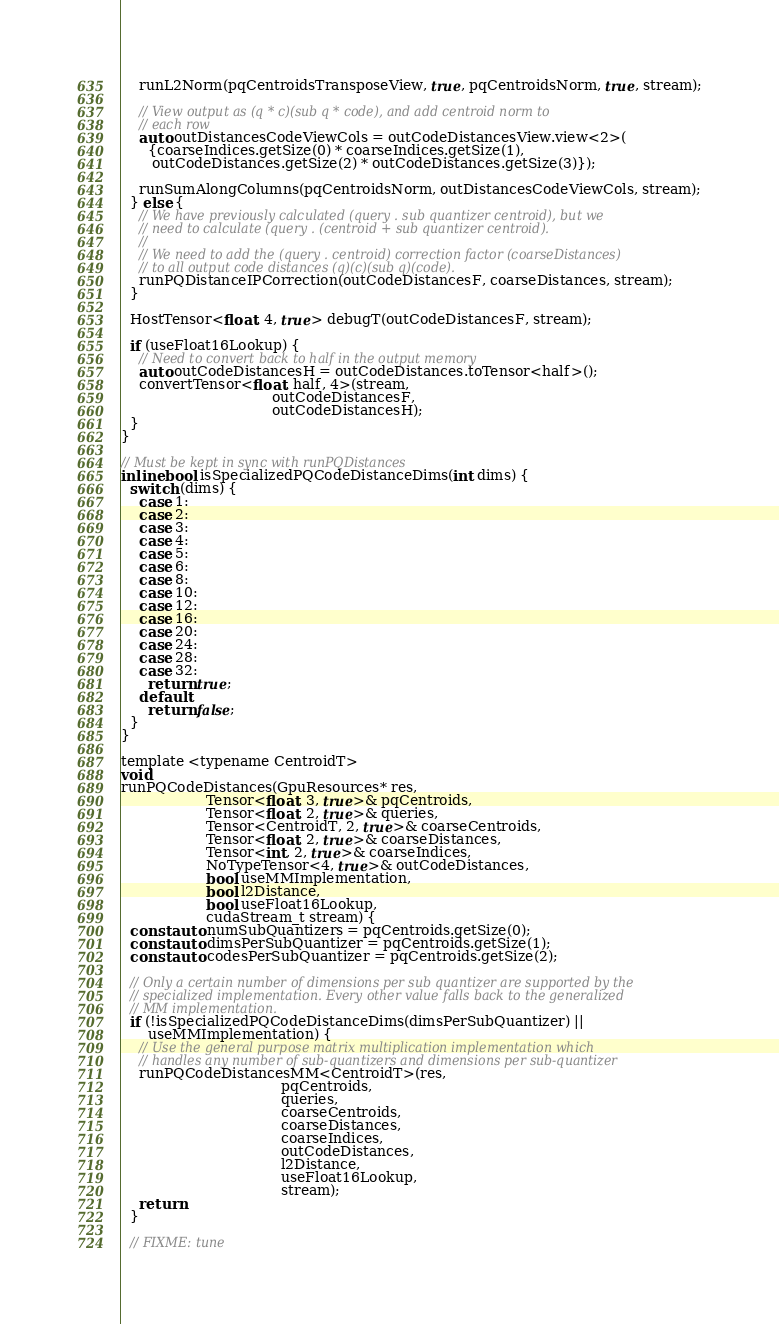<code> <loc_0><loc_0><loc_500><loc_500><_Cuda_>
    runL2Norm(pqCentroidsTransposeView, true, pqCentroidsNorm, true, stream);

    // View output as (q * c)(sub q * code), and add centroid norm to
    // each row
    auto outDistancesCodeViewCols = outCodeDistancesView.view<2>(
      {coarseIndices.getSize(0) * coarseIndices.getSize(1),
       outCodeDistances.getSize(2) * outCodeDistances.getSize(3)});

    runSumAlongColumns(pqCentroidsNorm, outDistancesCodeViewCols, stream);
  } else {
    // We have previously calculated (query . sub quantizer centroid), but we
    // need to calculate (query . (centroid + sub quantizer centroid).
    //
    // We need to add the (query . centroid) correction factor (coarseDistances)
    // to all output code distances (q)(c)(sub q)(code).
    runPQDistanceIPCorrection(outCodeDistancesF, coarseDistances, stream);
  }

  HostTensor<float, 4, true> debugT(outCodeDistancesF, stream);

  if (useFloat16Lookup) {
    // Need to convert back to half in the output memory
    auto outCodeDistancesH = outCodeDistances.toTensor<half>();
    convertTensor<float, half, 4>(stream,
                                  outCodeDistancesF,
                                  outCodeDistancesH);
  }
}

// Must be kept in sync with runPQDistances
inline bool isSpecializedPQCodeDistanceDims(int dims) {
  switch (dims) {
    case 1:
    case 2:
    case 3:
    case 4:
    case 5:
    case 6:
    case 8:
    case 10:
    case 12:
    case 16:
    case 20:
    case 24:
    case 28:
    case 32:
      return true;
    default:
      return false;
  }
}

template <typename CentroidT>
void
runPQCodeDistances(GpuResources* res,
                   Tensor<float, 3, true>& pqCentroids,
                   Tensor<float, 2, true>& queries,
                   Tensor<CentroidT, 2, true>& coarseCentroids,
                   Tensor<float, 2, true>& coarseDistances,
                   Tensor<int, 2, true>& coarseIndices,
                   NoTypeTensor<4, true>& outCodeDistances,
                   bool useMMImplementation,
                   bool l2Distance,
                   bool useFloat16Lookup,
                   cudaStream_t stream) {
  const auto numSubQuantizers = pqCentroids.getSize(0);
  const auto dimsPerSubQuantizer = pqCentroids.getSize(1);
  const auto codesPerSubQuantizer = pqCentroids.getSize(2);

  // Only a certain number of dimensions per sub quantizer are supported by the
  // specialized implementation. Every other value falls back to the generalized
  // MM implementation.
  if (!isSpecializedPQCodeDistanceDims(dimsPerSubQuantizer) ||
      useMMImplementation) {
    // Use the general purpose matrix multiplication implementation which
    // handles any number of sub-quantizers and dimensions per sub-quantizer
    runPQCodeDistancesMM<CentroidT>(res,
                                    pqCentroids,
                                    queries,
                                    coarseCentroids,
                                    coarseDistances,
                                    coarseIndices,
                                    outCodeDistances,
                                    l2Distance,
                                    useFloat16Lookup,
                                    stream);
    return;
  }

  // FIXME: tune</code> 